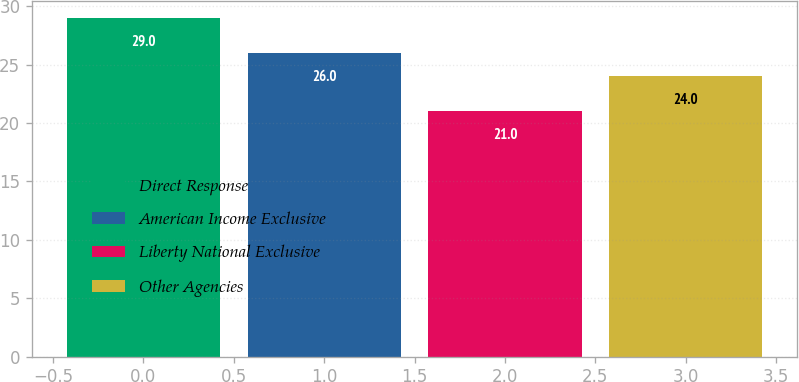Convert chart. <chart><loc_0><loc_0><loc_500><loc_500><bar_chart><fcel>Direct Response<fcel>American Income Exclusive<fcel>Liberty National Exclusive<fcel>Other Agencies<nl><fcel>29<fcel>26<fcel>21<fcel>24<nl></chart> 